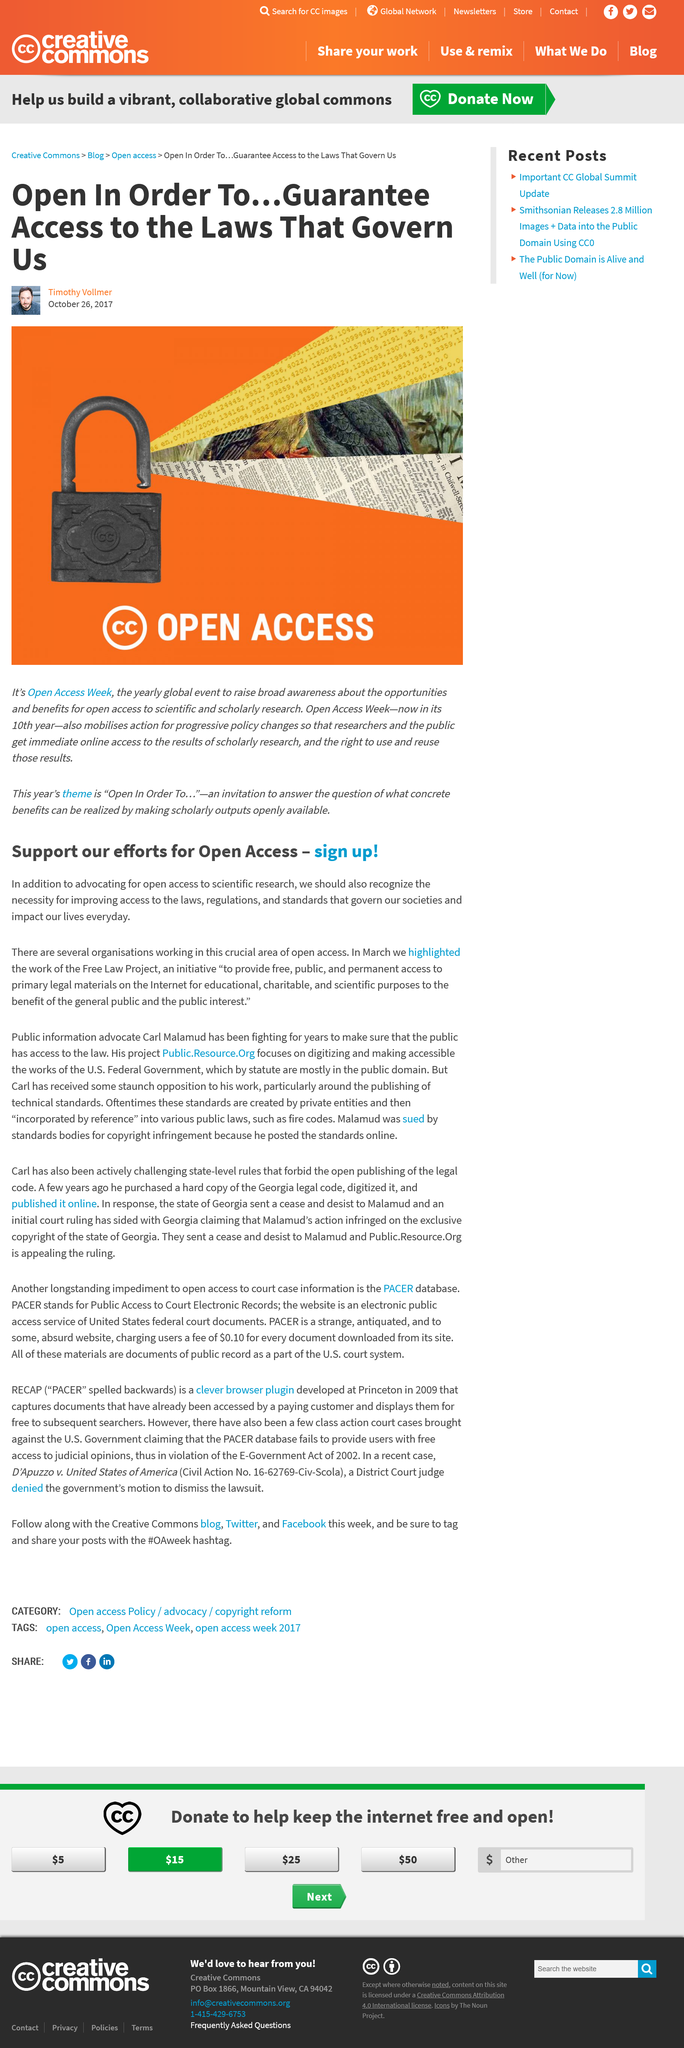List a handful of essential elements in this visual. In March, the work of the Free Law Project was highlighted as a necessity for improving access. The theme this year is "Open In Order To...", which emphasizes the importance of openness and collaboration in achieving one's goals and aspirations. The Free Law Project is an initiative aimed at providing free, public, and permanent access to primary legal materials on the internet. What is the event? It is Open Access Week. The purposes of access to law, regulations, and standards are for the benefit of the general public and the public interest. 